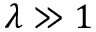Convert formula to latex. <formula><loc_0><loc_0><loc_500><loc_500>\lambda \gg 1</formula> 